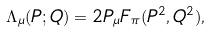<formula> <loc_0><loc_0><loc_500><loc_500>\Lambda _ { \mu } ( P ; Q ) = 2 P _ { \mu } F _ { \pi } ( P ^ { 2 } , Q ^ { 2 } ) ,</formula> 